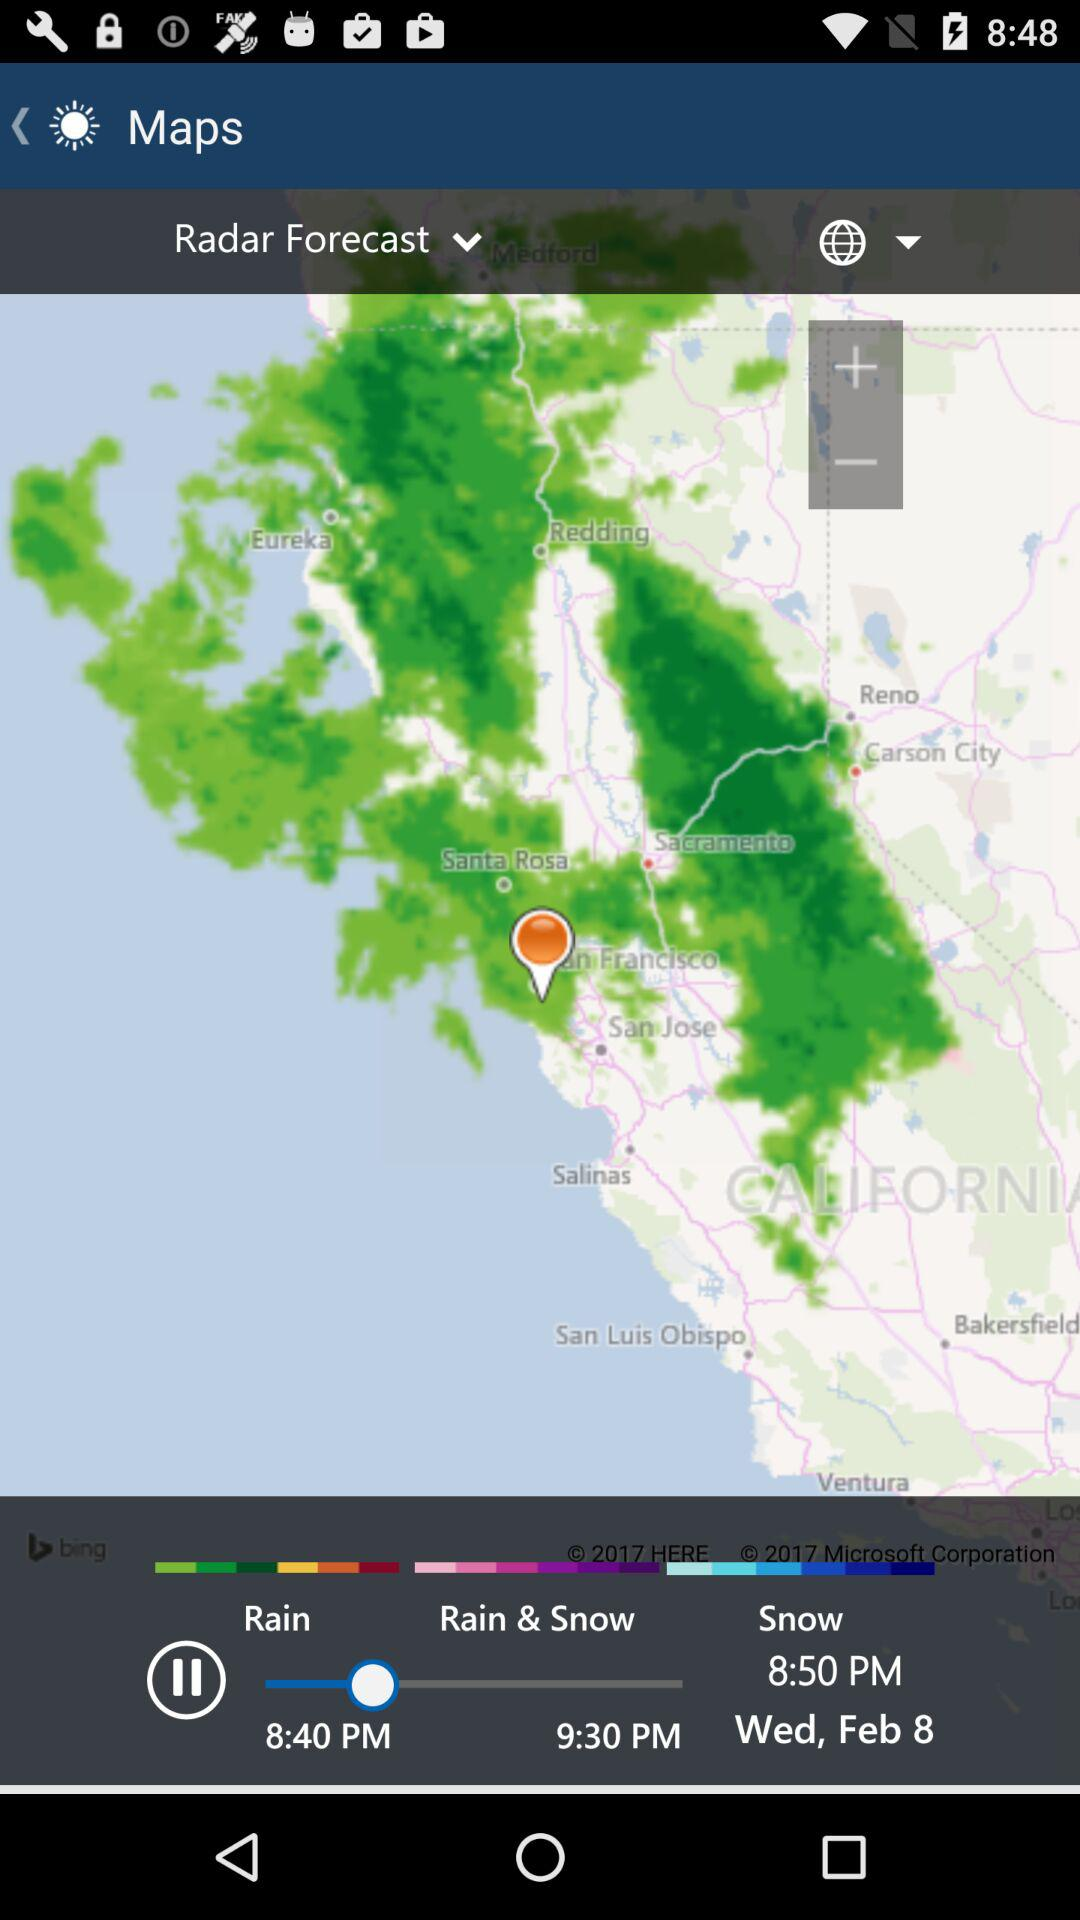How many different precipitation types are forecast?
Answer the question using a single word or phrase. 3 